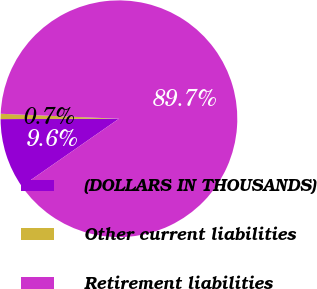Convert chart to OTSL. <chart><loc_0><loc_0><loc_500><loc_500><pie_chart><fcel>(DOLLARS IN THOUSANDS)<fcel>Other current liabilities<fcel>Retirement liabilities<nl><fcel>9.62%<fcel>0.72%<fcel>89.66%<nl></chart> 